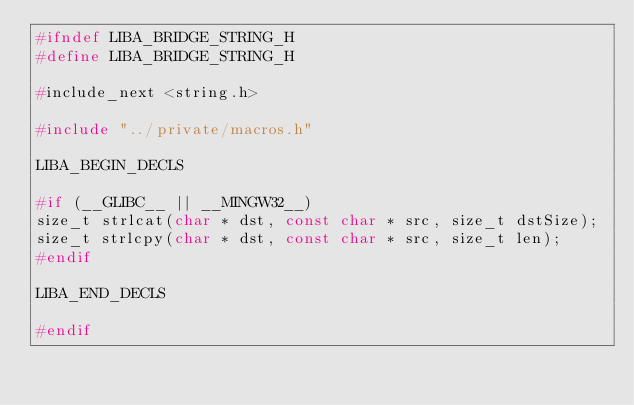<code> <loc_0><loc_0><loc_500><loc_500><_C_>#ifndef LIBA_BRIDGE_STRING_H
#define LIBA_BRIDGE_STRING_H

#include_next <string.h>

#include "../private/macros.h"

LIBA_BEGIN_DECLS

#if (__GLIBC__ || __MINGW32__)
size_t strlcat(char * dst, const char * src, size_t dstSize);
size_t strlcpy(char * dst, const char * src, size_t len);
#endif

LIBA_END_DECLS

#endif
</code> 